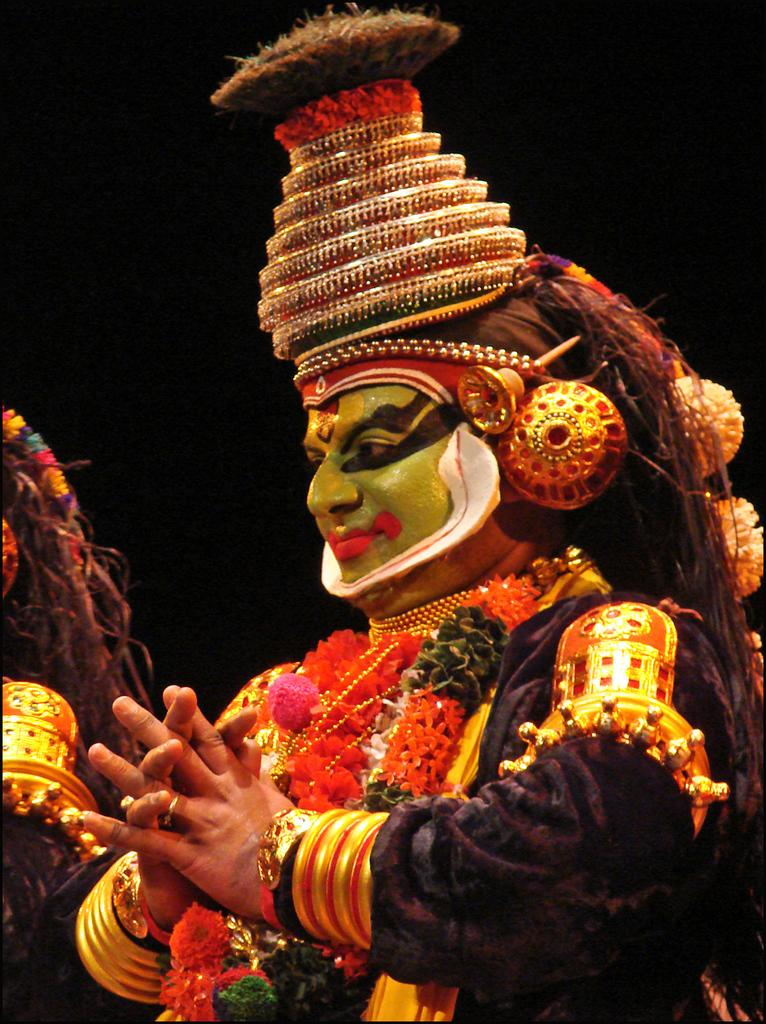What is the main subject of the image? There is a person in the image. What is the person wearing in the image? The person is wearing a costume. What type of milk is being crushed by the person's toe in the image? There is no milk or toe present in the image; the person is simply wearing a costume. 